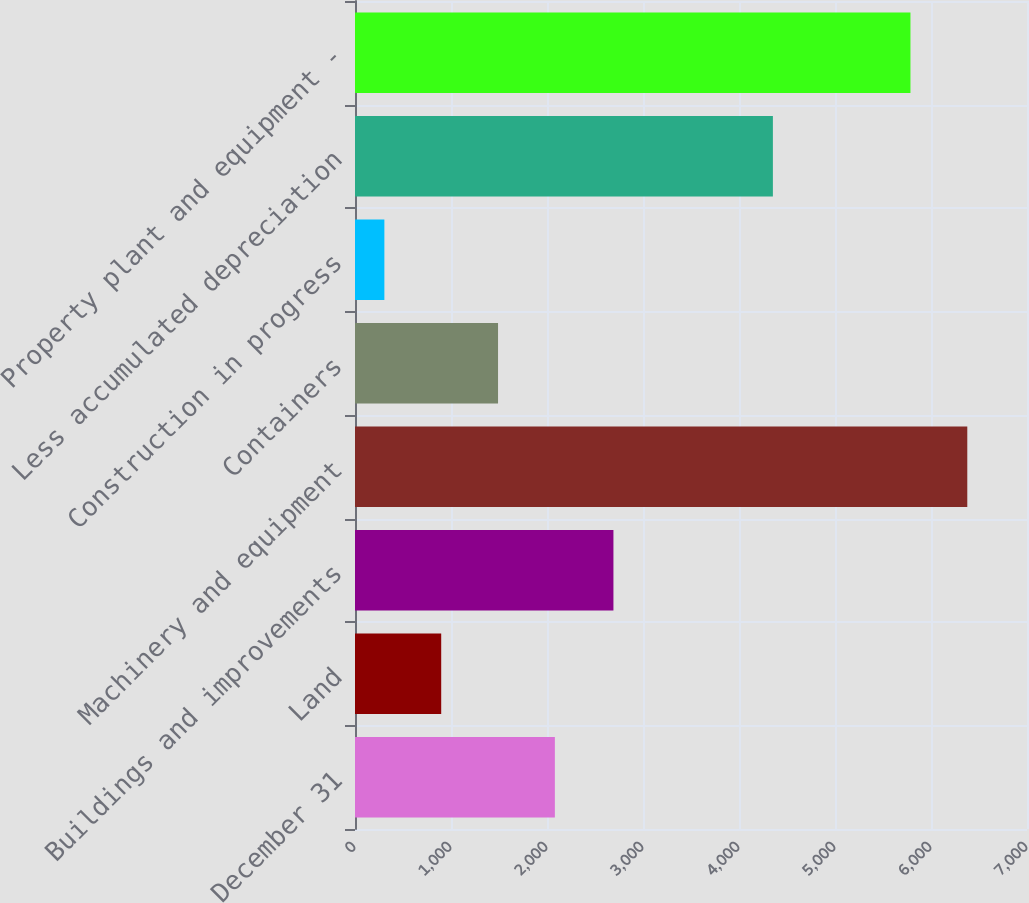Convert chart to OTSL. <chart><loc_0><loc_0><loc_500><loc_500><bar_chart><fcel>December 31<fcel>Land<fcel>Buildings and improvements<fcel>Machinery and equipment<fcel>Containers<fcel>Construction in progress<fcel>Less accumulated depreciation<fcel>Property plant and equipment -<nl><fcel>2082<fcel>898<fcel>2692<fcel>6378<fcel>1490<fcel>306<fcel>4353<fcel>5786<nl></chart> 